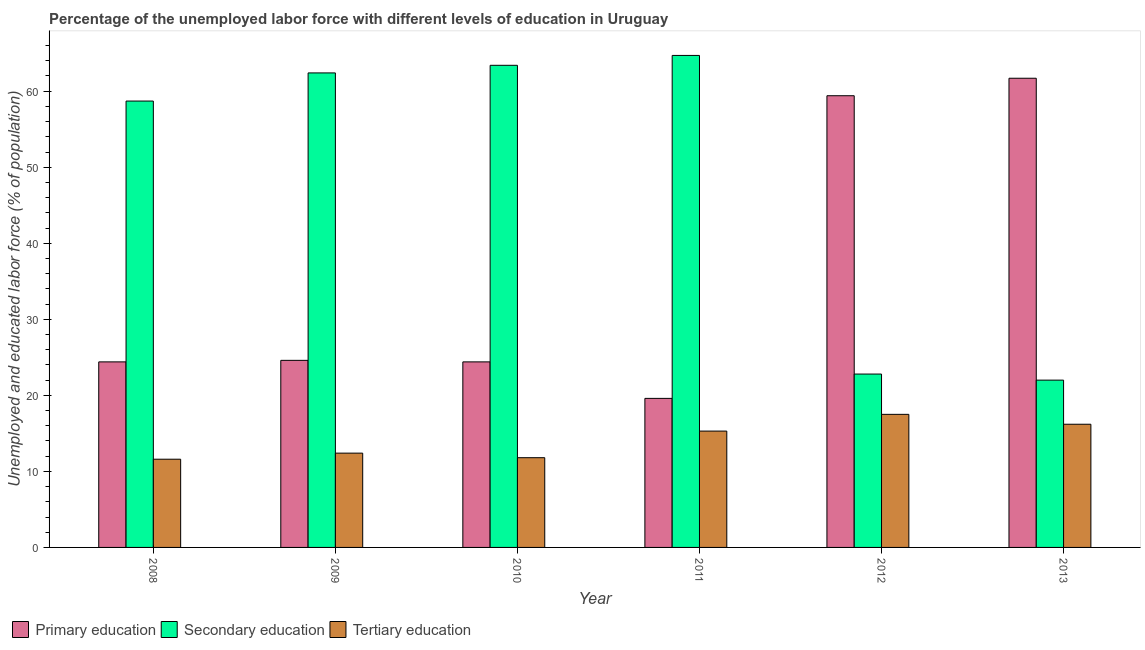How many groups of bars are there?
Provide a short and direct response. 6. Are the number of bars on each tick of the X-axis equal?
Make the answer very short. Yes. How many bars are there on the 6th tick from the left?
Make the answer very short. 3. What is the label of the 2nd group of bars from the left?
Provide a succinct answer. 2009. In how many cases, is the number of bars for a given year not equal to the number of legend labels?
Provide a short and direct response. 0. What is the percentage of labor force who received secondary education in 2011?
Offer a very short reply. 64.7. Across all years, what is the maximum percentage of labor force who received primary education?
Offer a terse response. 61.7. In which year was the percentage of labor force who received primary education maximum?
Offer a very short reply. 2013. What is the total percentage of labor force who received tertiary education in the graph?
Provide a short and direct response. 84.8. What is the difference between the percentage of labor force who received secondary education in 2008 and that in 2009?
Give a very brief answer. -3.7. What is the difference between the percentage of labor force who received tertiary education in 2008 and the percentage of labor force who received primary education in 2009?
Make the answer very short. -0.8. What is the average percentage of labor force who received secondary education per year?
Keep it short and to the point. 49. In the year 2011, what is the difference between the percentage of labor force who received primary education and percentage of labor force who received secondary education?
Your answer should be very brief. 0. In how many years, is the percentage of labor force who received secondary education greater than 62 %?
Your answer should be very brief. 3. What is the ratio of the percentage of labor force who received secondary education in 2012 to that in 2013?
Offer a very short reply. 1.04. What is the difference between the highest and the second highest percentage of labor force who received tertiary education?
Your answer should be very brief. 1.3. What is the difference between the highest and the lowest percentage of labor force who received tertiary education?
Make the answer very short. 5.9. Is the sum of the percentage of labor force who received primary education in 2011 and 2013 greater than the maximum percentage of labor force who received tertiary education across all years?
Offer a terse response. Yes. What does the 2nd bar from the left in 2013 represents?
Provide a short and direct response. Secondary education. What does the 2nd bar from the right in 2012 represents?
Offer a terse response. Secondary education. Is it the case that in every year, the sum of the percentage of labor force who received primary education and percentage of labor force who received secondary education is greater than the percentage of labor force who received tertiary education?
Your answer should be compact. Yes. Are all the bars in the graph horizontal?
Offer a terse response. No. What is the difference between two consecutive major ticks on the Y-axis?
Give a very brief answer. 10. Does the graph contain any zero values?
Give a very brief answer. No. How are the legend labels stacked?
Your answer should be compact. Horizontal. What is the title of the graph?
Keep it short and to the point. Percentage of the unemployed labor force with different levels of education in Uruguay. What is the label or title of the X-axis?
Provide a succinct answer. Year. What is the label or title of the Y-axis?
Offer a very short reply. Unemployed and educated labor force (% of population). What is the Unemployed and educated labor force (% of population) in Primary education in 2008?
Offer a terse response. 24.4. What is the Unemployed and educated labor force (% of population) of Secondary education in 2008?
Offer a terse response. 58.7. What is the Unemployed and educated labor force (% of population) in Tertiary education in 2008?
Your answer should be very brief. 11.6. What is the Unemployed and educated labor force (% of population) in Primary education in 2009?
Provide a short and direct response. 24.6. What is the Unemployed and educated labor force (% of population) of Secondary education in 2009?
Offer a very short reply. 62.4. What is the Unemployed and educated labor force (% of population) of Tertiary education in 2009?
Make the answer very short. 12.4. What is the Unemployed and educated labor force (% of population) in Primary education in 2010?
Keep it short and to the point. 24.4. What is the Unemployed and educated labor force (% of population) of Secondary education in 2010?
Ensure brevity in your answer.  63.4. What is the Unemployed and educated labor force (% of population) in Tertiary education in 2010?
Give a very brief answer. 11.8. What is the Unemployed and educated labor force (% of population) of Primary education in 2011?
Make the answer very short. 19.6. What is the Unemployed and educated labor force (% of population) of Secondary education in 2011?
Offer a terse response. 64.7. What is the Unemployed and educated labor force (% of population) of Tertiary education in 2011?
Provide a short and direct response. 15.3. What is the Unemployed and educated labor force (% of population) in Primary education in 2012?
Give a very brief answer. 59.4. What is the Unemployed and educated labor force (% of population) of Secondary education in 2012?
Provide a short and direct response. 22.8. What is the Unemployed and educated labor force (% of population) in Primary education in 2013?
Your answer should be very brief. 61.7. What is the Unemployed and educated labor force (% of population) in Tertiary education in 2013?
Keep it short and to the point. 16.2. Across all years, what is the maximum Unemployed and educated labor force (% of population) of Primary education?
Give a very brief answer. 61.7. Across all years, what is the maximum Unemployed and educated labor force (% of population) of Secondary education?
Ensure brevity in your answer.  64.7. Across all years, what is the maximum Unemployed and educated labor force (% of population) of Tertiary education?
Your response must be concise. 17.5. Across all years, what is the minimum Unemployed and educated labor force (% of population) in Primary education?
Give a very brief answer. 19.6. Across all years, what is the minimum Unemployed and educated labor force (% of population) of Secondary education?
Provide a short and direct response. 22. Across all years, what is the minimum Unemployed and educated labor force (% of population) in Tertiary education?
Your response must be concise. 11.6. What is the total Unemployed and educated labor force (% of population) in Primary education in the graph?
Offer a terse response. 214.1. What is the total Unemployed and educated labor force (% of population) of Secondary education in the graph?
Offer a terse response. 294. What is the total Unemployed and educated labor force (% of population) in Tertiary education in the graph?
Give a very brief answer. 84.8. What is the difference between the Unemployed and educated labor force (% of population) of Secondary education in 2008 and that in 2009?
Make the answer very short. -3.7. What is the difference between the Unemployed and educated labor force (% of population) of Tertiary education in 2008 and that in 2009?
Your answer should be very brief. -0.8. What is the difference between the Unemployed and educated labor force (% of population) in Primary education in 2008 and that in 2010?
Your answer should be very brief. 0. What is the difference between the Unemployed and educated labor force (% of population) in Primary education in 2008 and that in 2011?
Provide a succinct answer. 4.8. What is the difference between the Unemployed and educated labor force (% of population) in Secondary education in 2008 and that in 2011?
Ensure brevity in your answer.  -6. What is the difference between the Unemployed and educated labor force (% of population) in Tertiary education in 2008 and that in 2011?
Give a very brief answer. -3.7. What is the difference between the Unemployed and educated labor force (% of population) of Primary education in 2008 and that in 2012?
Ensure brevity in your answer.  -35. What is the difference between the Unemployed and educated labor force (% of population) in Secondary education in 2008 and that in 2012?
Offer a terse response. 35.9. What is the difference between the Unemployed and educated labor force (% of population) in Tertiary education in 2008 and that in 2012?
Your answer should be very brief. -5.9. What is the difference between the Unemployed and educated labor force (% of population) in Primary education in 2008 and that in 2013?
Provide a succinct answer. -37.3. What is the difference between the Unemployed and educated labor force (% of population) of Secondary education in 2008 and that in 2013?
Your answer should be very brief. 36.7. What is the difference between the Unemployed and educated labor force (% of population) in Secondary education in 2009 and that in 2010?
Your response must be concise. -1. What is the difference between the Unemployed and educated labor force (% of population) in Primary education in 2009 and that in 2011?
Make the answer very short. 5. What is the difference between the Unemployed and educated labor force (% of population) in Secondary education in 2009 and that in 2011?
Your answer should be very brief. -2.3. What is the difference between the Unemployed and educated labor force (% of population) in Tertiary education in 2009 and that in 2011?
Make the answer very short. -2.9. What is the difference between the Unemployed and educated labor force (% of population) in Primary education in 2009 and that in 2012?
Your response must be concise. -34.8. What is the difference between the Unemployed and educated labor force (% of population) of Secondary education in 2009 and that in 2012?
Offer a very short reply. 39.6. What is the difference between the Unemployed and educated labor force (% of population) of Tertiary education in 2009 and that in 2012?
Keep it short and to the point. -5.1. What is the difference between the Unemployed and educated labor force (% of population) in Primary education in 2009 and that in 2013?
Offer a terse response. -37.1. What is the difference between the Unemployed and educated labor force (% of population) in Secondary education in 2009 and that in 2013?
Your answer should be very brief. 40.4. What is the difference between the Unemployed and educated labor force (% of population) in Primary education in 2010 and that in 2011?
Your response must be concise. 4.8. What is the difference between the Unemployed and educated labor force (% of population) in Secondary education in 2010 and that in 2011?
Your answer should be compact. -1.3. What is the difference between the Unemployed and educated labor force (% of population) in Tertiary education in 2010 and that in 2011?
Keep it short and to the point. -3.5. What is the difference between the Unemployed and educated labor force (% of population) in Primary education in 2010 and that in 2012?
Make the answer very short. -35. What is the difference between the Unemployed and educated labor force (% of population) of Secondary education in 2010 and that in 2012?
Keep it short and to the point. 40.6. What is the difference between the Unemployed and educated labor force (% of population) of Tertiary education in 2010 and that in 2012?
Make the answer very short. -5.7. What is the difference between the Unemployed and educated labor force (% of population) in Primary education in 2010 and that in 2013?
Your answer should be very brief. -37.3. What is the difference between the Unemployed and educated labor force (% of population) of Secondary education in 2010 and that in 2013?
Your response must be concise. 41.4. What is the difference between the Unemployed and educated labor force (% of population) of Tertiary education in 2010 and that in 2013?
Make the answer very short. -4.4. What is the difference between the Unemployed and educated labor force (% of population) of Primary education in 2011 and that in 2012?
Make the answer very short. -39.8. What is the difference between the Unemployed and educated labor force (% of population) of Secondary education in 2011 and that in 2012?
Your response must be concise. 41.9. What is the difference between the Unemployed and educated labor force (% of population) in Primary education in 2011 and that in 2013?
Keep it short and to the point. -42.1. What is the difference between the Unemployed and educated labor force (% of population) in Secondary education in 2011 and that in 2013?
Offer a very short reply. 42.7. What is the difference between the Unemployed and educated labor force (% of population) of Tertiary education in 2011 and that in 2013?
Offer a terse response. -0.9. What is the difference between the Unemployed and educated labor force (% of population) of Tertiary education in 2012 and that in 2013?
Offer a very short reply. 1.3. What is the difference between the Unemployed and educated labor force (% of population) of Primary education in 2008 and the Unemployed and educated labor force (% of population) of Secondary education in 2009?
Give a very brief answer. -38. What is the difference between the Unemployed and educated labor force (% of population) of Primary education in 2008 and the Unemployed and educated labor force (% of population) of Tertiary education in 2009?
Your answer should be compact. 12. What is the difference between the Unemployed and educated labor force (% of population) in Secondary education in 2008 and the Unemployed and educated labor force (% of population) in Tertiary education in 2009?
Your response must be concise. 46.3. What is the difference between the Unemployed and educated labor force (% of population) of Primary education in 2008 and the Unemployed and educated labor force (% of population) of Secondary education in 2010?
Make the answer very short. -39. What is the difference between the Unemployed and educated labor force (% of population) of Secondary education in 2008 and the Unemployed and educated labor force (% of population) of Tertiary education in 2010?
Your answer should be very brief. 46.9. What is the difference between the Unemployed and educated labor force (% of population) in Primary education in 2008 and the Unemployed and educated labor force (% of population) in Secondary education in 2011?
Make the answer very short. -40.3. What is the difference between the Unemployed and educated labor force (% of population) of Secondary education in 2008 and the Unemployed and educated labor force (% of population) of Tertiary education in 2011?
Your answer should be compact. 43.4. What is the difference between the Unemployed and educated labor force (% of population) in Primary education in 2008 and the Unemployed and educated labor force (% of population) in Secondary education in 2012?
Provide a short and direct response. 1.6. What is the difference between the Unemployed and educated labor force (% of population) in Secondary education in 2008 and the Unemployed and educated labor force (% of population) in Tertiary education in 2012?
Offer a terse response. 41.2. What is the difference between the Unemployed and educated labor force (% of population) of Primary education in 2008 and the Unemployed and educated labor force (% of population) of Secondary education in 2013?
Offer a terse response. 2.4. What is the difference between the Unemployed and educated labor force (% of population) of Primary education in 2008 and the Unemployed and educated labor force (% of population) of Tertiary education in 2013?
Your response must be concise. 8.2. What is the difference between the Unemployed and educated labor force (% of population) in Secondary education in 2008 and the Unemployed and educated labor force (% of population) in Tertiary education in 2013?
Your answer should be very brief. 42.5. What is the difference between the Unemployed and educated labor force (% of population) in Primary education in 2009 and the Unemployed and educated labor force (% of population) in Secondary education in 2010?
Keep it short and to the point. -38.8. What is the difference between the Unemployed and educated labor force (% of population) in Primary education in 2009 and the Unemployed and educated labor force (% of population) in Tertiary education in 2010?
Provide a short and direct response. 12.8. What is the difference between the Unemployed and educated labor force (% of population) in Secondary education in 2009 and the Unemployed and educated labor force (% of population) in Tertiary education in 2010?
Offer a terse response. 50.6. What is the difference between the Unemployed and educated labor force (% of population) in Primary education in 2009 and the Unemployed and educated labor force (% of population) in Secondary education in 2011?
Offer a very short reply. -40.1. What is the difference between the Unemployed and educated labor force (% of population) of Primary education in 2009 and the Unemployed and educated labor force (% of population) of Tertiary education in 2011?
Make the answer very short. 9.3. What is the difference between the Unemployed and educated labor force (% of population) in Secondary education in 2009 and the Unemployed and educated labor force (% of population) in Tertiary education in 2011?
Give a very brief answer. 47.1. What is the difference between the Unemployed and educated labor force (% of population) in Primary education in 2009 and the Unemployed and educated labor force (% of population) in Tertiary education in 2012?
Your answer should be very brief. 7.1. What is the difference between the Unemployed and educated labor force (% of population) in Secondary education in 2009 and the Unemployed and educated labor force (% of population) in Tertiary education in 2012?
Offer a terse response. 44.9. What is the difference between the Unemployed and educated labor force (% of population) in Secondary education in 2009 and the Unemployed and educated labor force (% of population) in Tertiary education in 2013?
Offer a terse response. 46.2. What is the difference between the Unemployed and educated labor force (% of population) in Primary education in 2010 and the Unemployed and educated labor force (% of population) in Secondary education in 2011?
Ensure brevity in your answer.  -40.3. What is the difference between the Unemployed and educated labor force (% of population) of Secondary education in 2010 and the Unemployed and educated labor force (% of population) of Tertiary education in 2011?
Offer a terse response. 48.1. What is the difference between the Unemployed and educated labor force (% of population) in Primary education in 2010 and the Unemployed and educated labor force (% of population) in Tertiary education in 2012?
Provide a succinct answer. 6.9. What is the difference between the Unemployed and educated labor force (% of population) in Secondary education in 2010 and the Unemployed and educated labor force (% of population) in Tertiary education in 2012?
Offer a terse response. 45.9. What is the difference between the Unemployed and educated labor force (% of population) in Primary education in 2010 and the Unemployed and educated labor force (% of population) in Tertiary education in 2013?
Your response must be concise. 8.2. What is the difference between the Unemployed and educated labor force (% of population) of Secondary education in 2010 and the Unemployed and educated labor force (% of population) of Tertiary education in 2013?
Ensure brevity in your answer.  47.2. What is the difference between the Unemployed and educated labor force (% of population) of Secondary education in 2011 and the Unemployed and educated labor force (% of population) of Tertiary education in 2012?
Offer a very short reply. 47.2. What is the difference between the Unemployed and educated labor force (% of population) in Primary education in 2011 and the Unemployed and educated labor force (% of population) in Tertiary education in 2013?
Your answer should be compact. 3.4. What is the difference between the Unemployed and educated labor force (% of population) in Secondary education in 2011 and the Unemployed and educated labor force (% of population) in Tertiary education in 2013?
Provide a short and direct response. 48.5. What is the difference between the Unemployed and educated labor force (% of population) in Primary education in 2012 and the Unemployed and educated labor force (% of population) in Secondary education in 2013?
Provide a short and direct response. 37.4. What is the difference between the Unemployed and educated labor force (% of population) of Primary education in 2012 and the Unemployed and educated labor force (% of population) of Tertiary education in 2013?
Provide a succinct answer. 43.2. What is the difference between the Unemployed and educated labor force (% of population) of Secondary education in 2012 and the Unemployed and educated labor force (% of population) of Tertiary education in 2013?
Ensure brevity in your answer.  6.6. What is the average Unemployed and educated labor force (% of population) of Primary education per year?
Provide a succinct answer. 35.68. What is the average Unemployed and educated labor force (% of population) in Secondary education per year?
Keep it short and to the point. 49. What is the average Unemployed and educated labor force (% of population) in Tertiary education per year?
Offer a terse response. 14.13. In the year 2008, what is the difference between the Unemployed and educated labor force (% of population) of Primary education and Unemployed and educated labor force (% of population) of Secondary education?
Your answer should be compact. -34.3. In the year 2008, what is the difference between the Unemployed and educated labor force (% of population) in Primary education and Unemployed and educated labor force (% of population) in Tertiary education?
Make the answer very short. 12.8. In the year 2008, what is the difference between the Unemployed and educated labor force (% of population) of Secondary education and Unemployed and educated labor force (% of population) of Tertiary education?
Ensure brevity in your answer.  47.1. In the year 2009, what is the difference between the Unemployed and educated labor force (% of population) of Primary education and Unemployed and educated labor force (% of population) of Secondary education?
Your answer should be compact. -37.8. In the year 2010, what is the difference between the Unemployed and educated labor force (% of population) of Primary education and Unemployed and educated labor force (% of population) of Secondary education?
Make the answer very short. -39. In the year 2010, what is the difference between the Unemployed and educated labor force (% of population) of Secondary education and Unemployed and educated labor force (% of population) of Tertiary education?
Give a very brief answer. 51.6. In the year 2011, what is the difference between the Unemployed and educated labor force (% of population) in Primary education and Unemployed and educated labor force (% of population) in Secondary education?
Your answer should be compact. -45.1. In the year 2011, what is the difference between the Unemployed and educated labor force (% of population) of Primary education and Unemployed and educated labor force (% of population) of Tertiary education?
Make the answer very short. 4.3. In the year 2011, what is the difference between the Unemployed and educated labor force (% of population) in Secondary education and Unemployed and educated labor force (% of population) in Tertiary education?
Offer a terse response. 49.4. In the year 2012, what is the difference between the Unemployed and educated labor force (% of population) of Primary education and Unemployed and educated labor force (% of population) of Secondary education?
Provide a succinct answer. 36.6. In the year 2012, what is the difference between the Unemployed and educated labor force (% of population) of Primary education and Unemployed and educated labor force (% of population) of Tertiary education?
Provide a short and direct response. 41.9. In the year 2013, what is the difference between the Unemployed and educated labor force (% of population) of Primary education and Unemployed and educated labor force (% of population) of Secondary education?
Make the answer very short. 39.7. In the year 2013, what is the difference between the Unemployed and educated labor force (% of population) of Primary education and Unemployed and educated labor force (% of population) of Tertiary education?
Provide a succinct answer. 45.5. What is the ratio of the Unemployed and educated labor force (% of population) of Primary education in 2008 to that in 2009?
Your answer should be very brief. 0.99. What is the ratio of the Unemployed and educated labor force (% of population) of Secondary education in 2008 to that in 2009?
Provide a succinct answer. 0.94. What is the ratio of the Unemployed and educated labor force (% of population) of Tertiary education in 2008 to that in 2009?
Offer a very short reply. 0.94. What is the ratio of the Unemployed and educated labor force (% of population) of Primary education in 2008 to that in 2010?
Keep it short and to the point. 1. What is the ratio of the Unemployed and educated labor force (% of population) in Secondary education in 2008 to that in 2010?
Give a very brief answer. 0.93. What is the ratio of the Unemployed and educated labor force (% of population) of Tertiary education in 2008 to that in 2010?
Provide a succinct answer. 0.98. What is the ratio of the Unemployed and educated labor force (% of population) of Primary education in 2008 to that in 2011?
Provide a succinct answer. 1.24. What is the ratio of the Unemployed and educated labor force (% of population) in Secondary education in 2008 to that in 2011?
Provide a succinct answer. 0.91. What is the ratio of the Unemployed and educated labor force (% of population) of Tertiary education in 2008 to that in 2011?
Ensure brevity in your answer.  0.76. What is the ratio of the Unemployed and educated labor force (% of population) in Primary education in 2008 to that in 2012?
Offer a terse response. 0.41. What is the ratio of the Unemployed and educated labor force (% of population) in Secondary education in 2008 to that in 2012?
Provide a succinct answer. 2.57. What is the ratio of the Unemployed and educated labor force (% of population) in Tertiary education in 2008 to that in 2012?
Provide a succinct answer. 0.66. What is the ratio of the Unemployed and educated labor force (% of population) in Primary education in 2008 to that in 2013?
Ensure brevity in your answer.  0.4. What is the ratio of the Unemployed and educated labor force (% of population) in Secondary education in 2008 to that in 2013?
Offer a very short reply. 2.67. What is the ratio of the Unemployed and educated labor force (% of population) in Tertiary education in 2008 to that in 2013?
Provide a succinct answer. 0.72. What is the ratio of the Unemployed and educated labor force (% of population) of Primary education in 2009 to that in 2010?
Keep it short and to the point. 1.01. What is the ratio of the Unemployed and educated labor force (% of population) in Secondary education in 2009 to that in 2010?
Offer a terse response. 0.98. What is the ratio of the Unemployed and educated labor force (% of population) in Tertiary education in 2009 to that in 2010?
Provide a succinct answer. 1.05. What is the ratio of the Unemployed and educated labor force (% of population) in Primary education in 2009 to that in 2011?
Your answer should be very brief. 1.26. What is the ratio of the Unemployed and educated labor force (% of population) in Secondary education in 2009 to that in 2011?
Give a very brief answer. 0.96. What is the ratio of the Unemployed and educated labor force (% of population) of Tertiary education in 2009 to that in 2011?
Make the answer very short. 0.81. What is the ratio of the Unemployed and educated labor force (% of population) of Primary education in 2009 to that in 2012?
Provide a succinct answer. 0.41. What is the ratio of the Unemployed and educated labor force (% of population) in Secondary education in 2009 to that in 2012?
Give a very brief answer. 2.74. What is the ratio of the Unemployed and educated labor force (% of population) of Tertiary education in 2009 to that in 2012?
Your answer should be compact. 0.71. What is the ratio of the Unemployed and educated labor force (% of population) in Primary education in 2009 to that in 2013?
Make the answer very short. 0.4. What is the ratio of the Unemployed and educated labor force (% of population) of Secondary education in 2009 to that in 2013?
Offer a very short reply. 2.84. What is the ratio of the Unemployed and educated labor force (% of population) in Tertiary education in 2009 to that in 2013?
Your answer should be compact. 0.77. What is the ratio of the Unemployed and educated labor force (% of population) in Primary education in 2010 to that in 2011?
Provide a succinct answer. 1.24. What is the ratio of the Unemployed and educated labor force (% of population) in Secondary education in 2010 to that in 2011?
Give a very brief answer. 0.98. What is the ratio of the Unemployed and educated labor force (% of population) in Tertiary education in 2010 to that in 2011?
Offer a very short reply. 0.77. What is the ratio of the Unemployed and educated labor force (% of population) of Primary education in 2010 to that in 2012?
Keep it short and to the point. 0.41. What is the ratio of the Unemployed and educated labor force (% of population) of Secondary education in 2010 to that in 2012?
Provide a succinct answer. 2.78. What is the ratio of the Unemployed and educated labor force (% of population) in Tertiary education in 2010 to that in 2012?
Offer a terse response. 0.67. What is the ratio of the Unemployed and educated labor force (% of population) in Primary education in 2010 to that in 2013?
Offer a terse response. 0.4. What is the ratio of the Unemployed and educated labor force (% of population) in Secondary education in 2010 to that in 2013?
Provide a short and direct response. 2.88. What is the ratio of the Unemployed and educated labor force (% of population) of Tertiary education in 2010 to that in 2013?
Your response must be concise. 0.73. What is the ratio of the Unemployed and educated labor force (% of population) of Primary education in 2011 to that in 2012?
Your response must be concise. 0.33. What is the ratio of the Unemployed and educated labor force (% of population) of Secondary education in 2011 to that in 2012?
Your response must be concise. 2.84. What is the ratio of the Unemployed and educated labor force (% of population) of Tertiary education in 2011 to that in 2012?
Give a very brief answer. 0.87. What is the ratio of the Unemployed and educated labor force (% of population) in Primary education in 2011 to that in 2013?
Offer a very short reply. 0.32. What is the ratio of the Unemployed and educated labor force (% of population) in Secondary education in 2011 to that in 2013?
Offer a very short reply. 2.94. What is the ratio of the Unemployed and educated labor force (% of population) in Tertiary education in 2011 to that in 2013?
Make the answer very short. 0.94. What is the ratio of the Unemployed and educated labor force (% of population) of Primary education in 2012 to that in 2013?
Your answer should be compact. 0.96. What is the ratio of the Unemployed and educated labor force (% of population) of Secondary education in 2012 to that in 2013?
Provide a short and direct response. 1.04. What is the ratio of the Unemployed and educated labor force (% of population) in Tertiary education in 2012 to that in 2013?
Make the answer very short. 1.08. What is the difference between the highest and the second highest Unemployed and educated labor force (% of population) in Primary education?
Provide a succinct answer. 2.3. What is the difference between the highest and the lowest Unemployed and educated labor force (% of population) in Primary education?
Ensure brevity in your answer.  42.1. What is the difference between the highest and the lowest Unemployed and educated labor force (% of population) in Secondary education?
Provide a short and direct response. 42.7. 